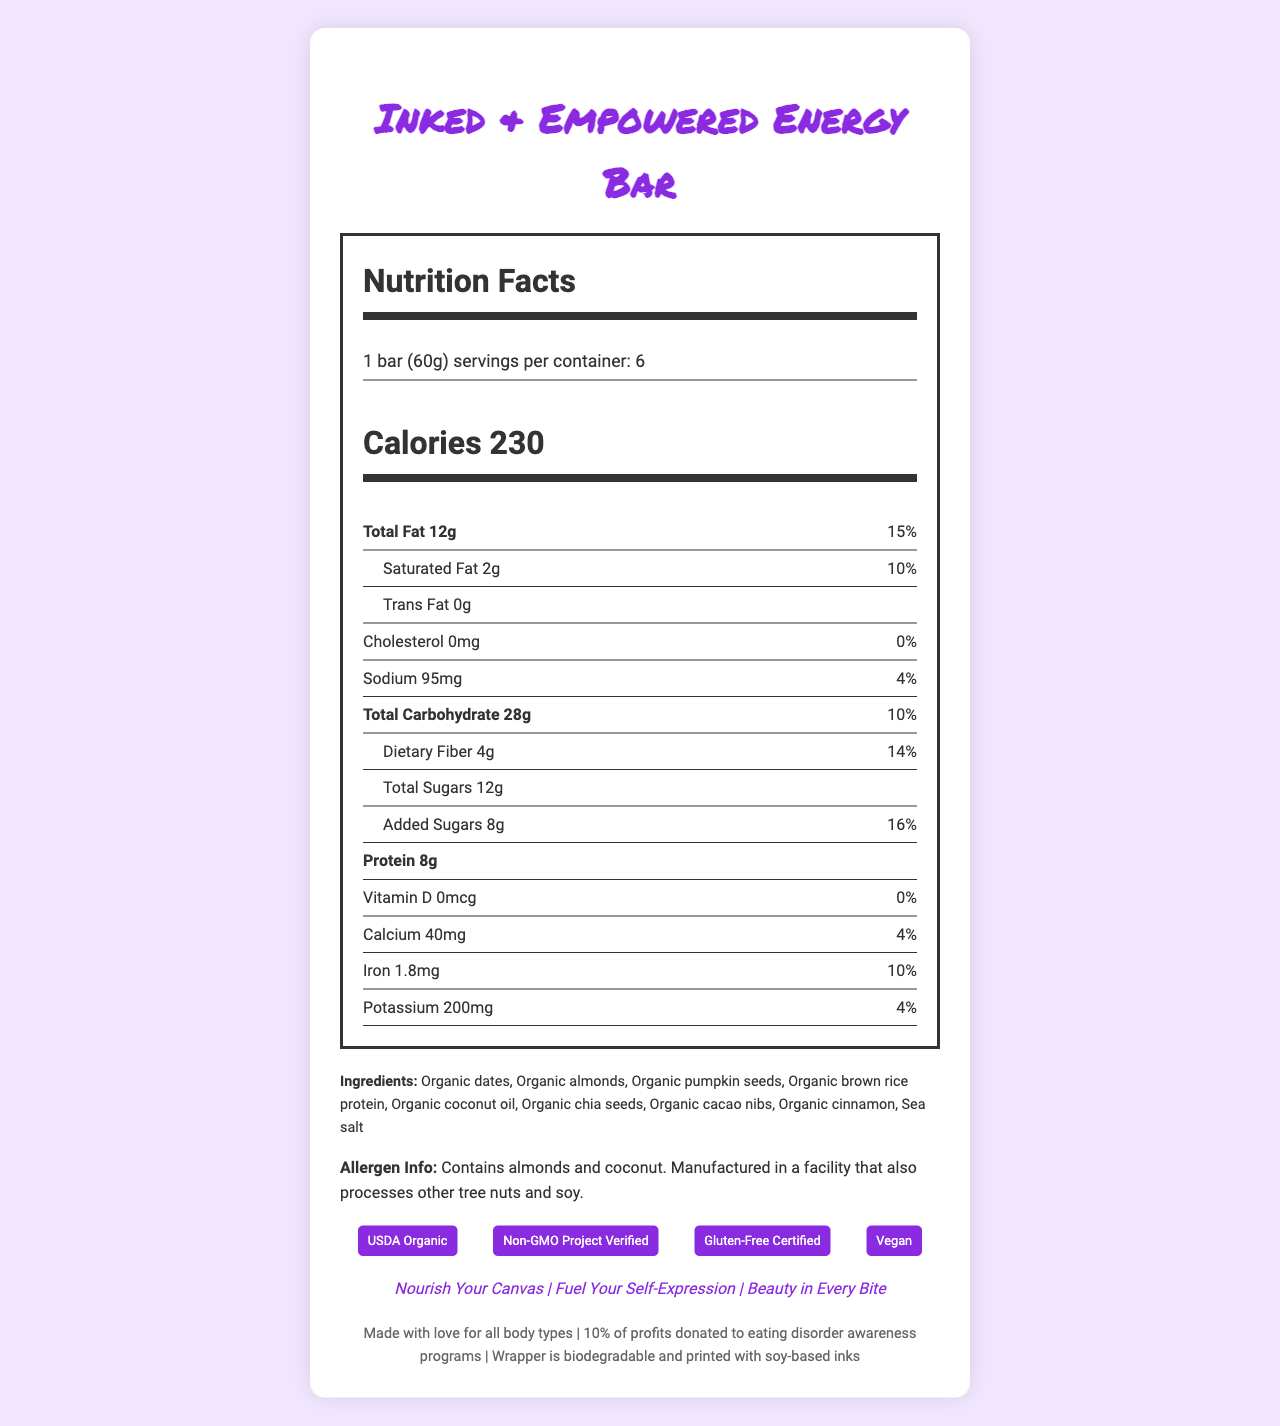what is the serving size of the Inked & Empowered Energy Bar? The serving size is clearly stated at the top of the Nutrition Facts section as "1 bar (60g)".
Answer: 1 bar (60g) how many calories are in one serving of the Inked & Empowered Energy Bar? The calories per serving are listed prominently under the serving size information with "Calories 230".
Answer: 230 calories how much protein does one bar contain? The amount of protein is listed under the nutrients section with "Protein 8g".
Answer: 8g how much total fat is in one bar and what is the daily value percentage? The total fat content is stated as "Total Fat 12g" and its daily value percentage is given as 15%.
Answer: 12g, 15% which certifications does the product have? The certifications are listed at the bottom of the document in a section labelled "certifications".
Answer: USDA Organic, Non-GMO Project Verified, Gluten-Free Certified, Vegan how many servings are there per container? A. 4 B. 6 C. 8 The number of servings per container is specified at the top of the Nutrition Facts section with "servings per container: 6".
Answer: B. 6 what is the main idea conveyed by the body-positive slogans on the packaging? A. Encourage weight loss B. Promote body positivity and self-expression C. Emphasize sugar-free content The body-positive slogans listed are oriented towards nourishing, fueling self-expression, and appreciating beauty in every bite. This promotes body positivity and self-expression.
Answer: B. Promote body positivity and self-expression does the energy bar contain any added sugars? The document lists "Added Sugars 8g" under the nutrients section.
Answer: Yes is the Inked & Empowered Energy Bar suitable for people with nut allergies? The allergen information states that the product contains almonds and coconut and is manufactured in a facility that also processes other tree nuts and soy.
Answer: No describe the entire document. The document is an extensive Nutrition Facts Label containing nutritional details, ingredients, allergen information, certifications, body-positive messaging, and additional insights about the product and company ethics.
Answer: The Nutrition Facts Label for the Inked & Empowered Energy Bar provides detailed nutritional information for the product, including servings per container, calories, and various nutrient amounts. It lists both total and specific fat, cholesterol, sodium, carbohydrates, sugars, protein, vitamins, and minerals. Ingredients and allergen information are provided, as well as certifications that highlight its organic, non-GMO, gluten-free, and vegan qualities. The document also includes body-positive slogans and additional information about the packaging and the company's commitment to social causes. what are the ingredients in the Inked & Empowered Energy Bar? The ingredients are listed in a dedicated section under the Nutrition Facts.
Answer: Organic dates, Organic almonds, Organic pumpkin seeds, Organic brown rice protein, Organic coconut oil, Organic chia seeds, Organic cacao nibs, Organic cinnamon, Sea salt how much sodium does the bar contain? The sodium content is listed as "Sodium 95mg" under the nutrient section.
Answer: 95mg how much of the daily value of calcium does one bar provide? The percentage daily value for calcium is given as 4% in the nutrient information section.
Answer: 4% is this product gluten-free? The document includes a "Gluten-Free Certified" certification.
Answer: Yes what are the slogans used on this product's packaging? The slogans are provided in the section entitled "body positive slogans".
Answer: Nourish Your Canvas, Fuel Your Self-Expression, Beauty in Every Bite who manufactures the Inked & Empowered Energy Bar? Manufacturer information is not provided in the document text.
Answer: Cannot be determined 